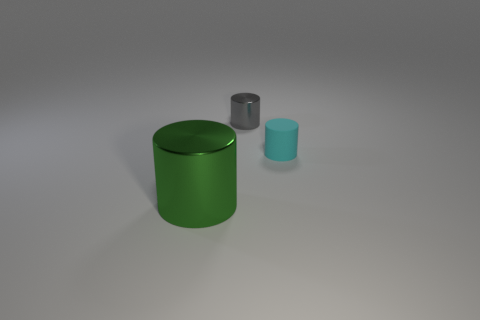Is the material of the tiny thing right of the gray object the same as the small object on the left side of the cyan matte cylinder? Based on the visual information, the small object to the right of the gray item does not seem to have the same surface texture or reflection as the small item next to the cyan matte cylinder, indicating that they are likely made of different materials. 